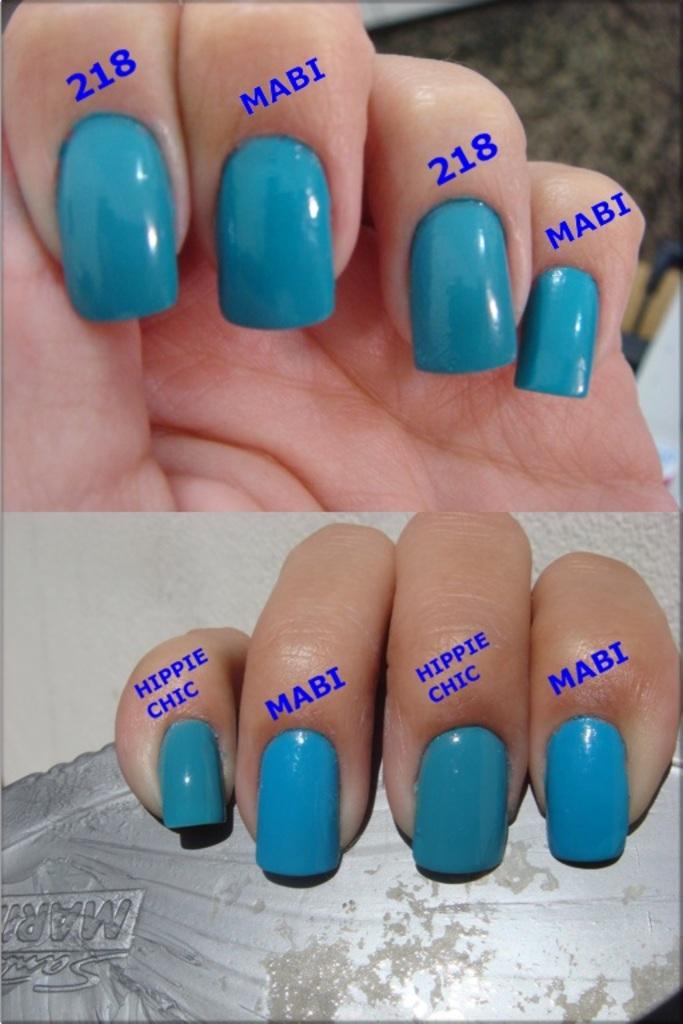What's the label of the bottom left finger?
Provide a succinct answer. Hippie chic. What is the number on one of the top fingers?
Keep it short and to the point. 218. 